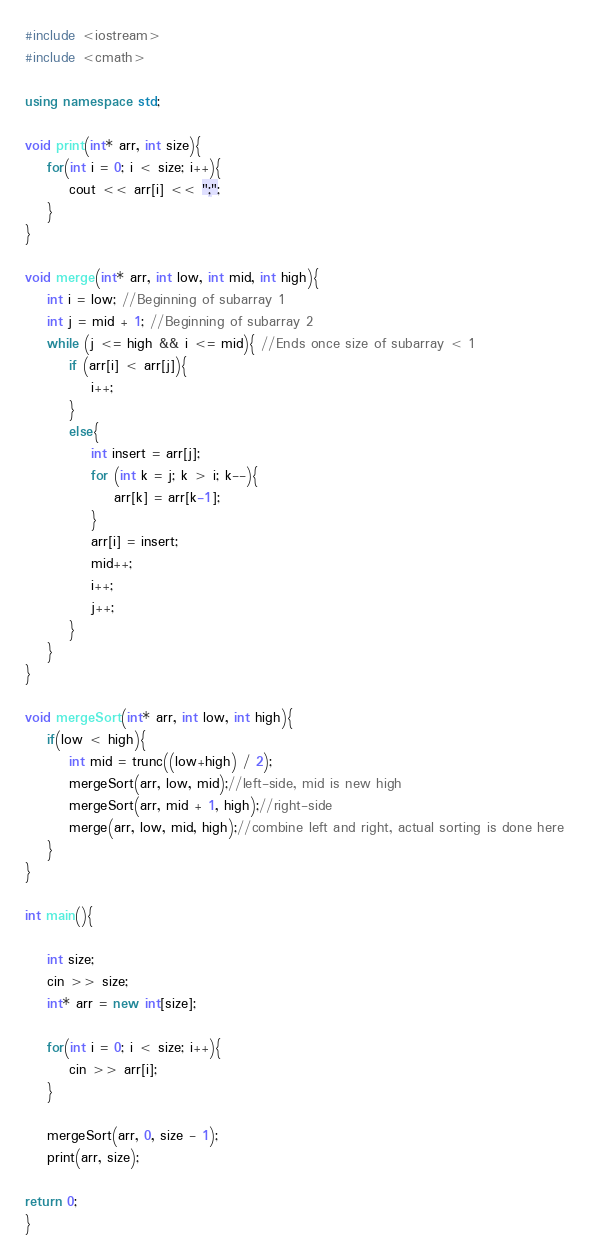<code> <loc_0><loc_0><loc_500><loc_500><_C++_>#include <iostream>
#include <cmath>

using namespace std;

void print(int* arr, int size){
    for(int i = 0; i < size; i++){
        cout << arr[i] << ";";
    }
}

void merge(int* arr, int low, int mid, int high){
    int i = low; //Beginning of subarray 1
    int j = mid + 1; //Beginning of subarray 2
    while (j <= high && i <= mid){ //Ends once size of subarray < 1 
        if (arr[i] < arr[j]){ 
            i++;
        }
        else{
            int insert = arr[j];
            for (int k = j; k > i; k--){
                arr[k] = arr[k-1];
            }
            arr[i] = insert;
            mid++;
            i++;
            j++;
        }
    }
}

void mergeSort(int* arr, int low, int high){
    if(low < high){
        int mid = trunc((low+high) / 2);
        mergeSort(arr, low, mid);//left-side, mid is new high
        mergeSort(arr, mid + 1, high);//right-side
        merge(arr, low, mid, high);//combine left and right, actual sorting is done here
    }
}

int main(){

    int size;
    cin >> size;
    int* arr = new int[size];

    for(int i = 0; i < size; i++){
        cin >> arr[i];
    }

    mergeSort(arr, 0, size - 1);
    print(arr, size);

return 0;
}</code> 